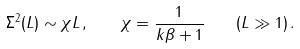Convert formula to latex. <formula><loc_0><loc_0><loc_500><loc_500>\Sigma ^ { 2 } ( L ) \sim \chi L \, , \quad \chi = \frac { 1 } { k \beta + 1 } \quad ( L \gg 1 ) \, .</formula> 